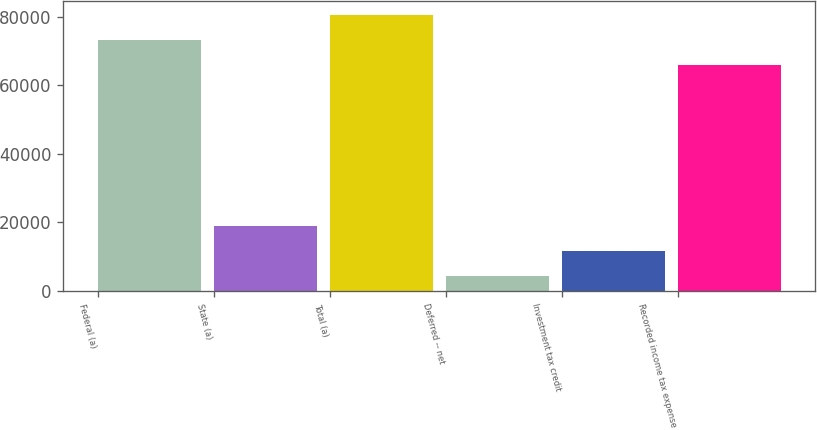Convert chart to OTSL. <chart><loc_0><loc_0><loc_500><loc_500><bar_chart><fcel>Federal (a)<fcel>State (a)<fcel>Total (a)<fcel>Deferred -- net<fcel>Investment tax credit<fcel>Recorded income tax expense<nl><fcel>73333.2<fcel>18882.4<fcel>80669.4<fcel>4210<fcel>11546.2<fcel>65997<nl></chart> 